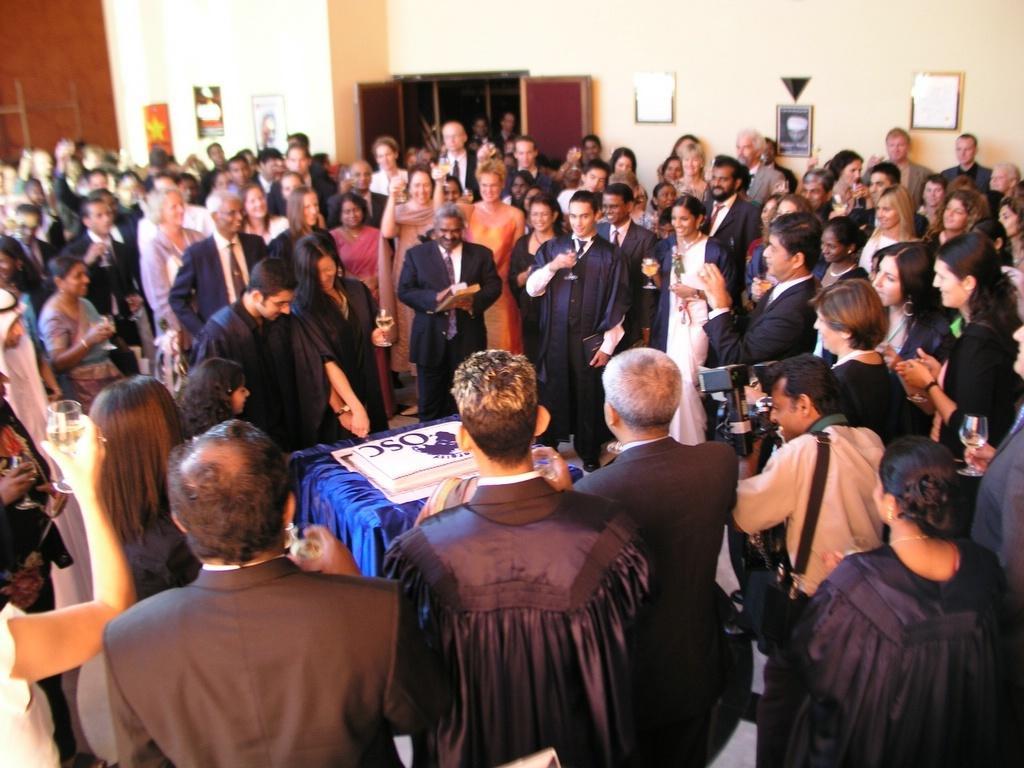How would you summarize this image in a sentence or two? In the foreground of this image, there are persons standing around a table on which a cake is placed on it. Few of them are holding glasses and a person is holding camera on the right. In the background, there is a wall, few frames on the wall and a window. 